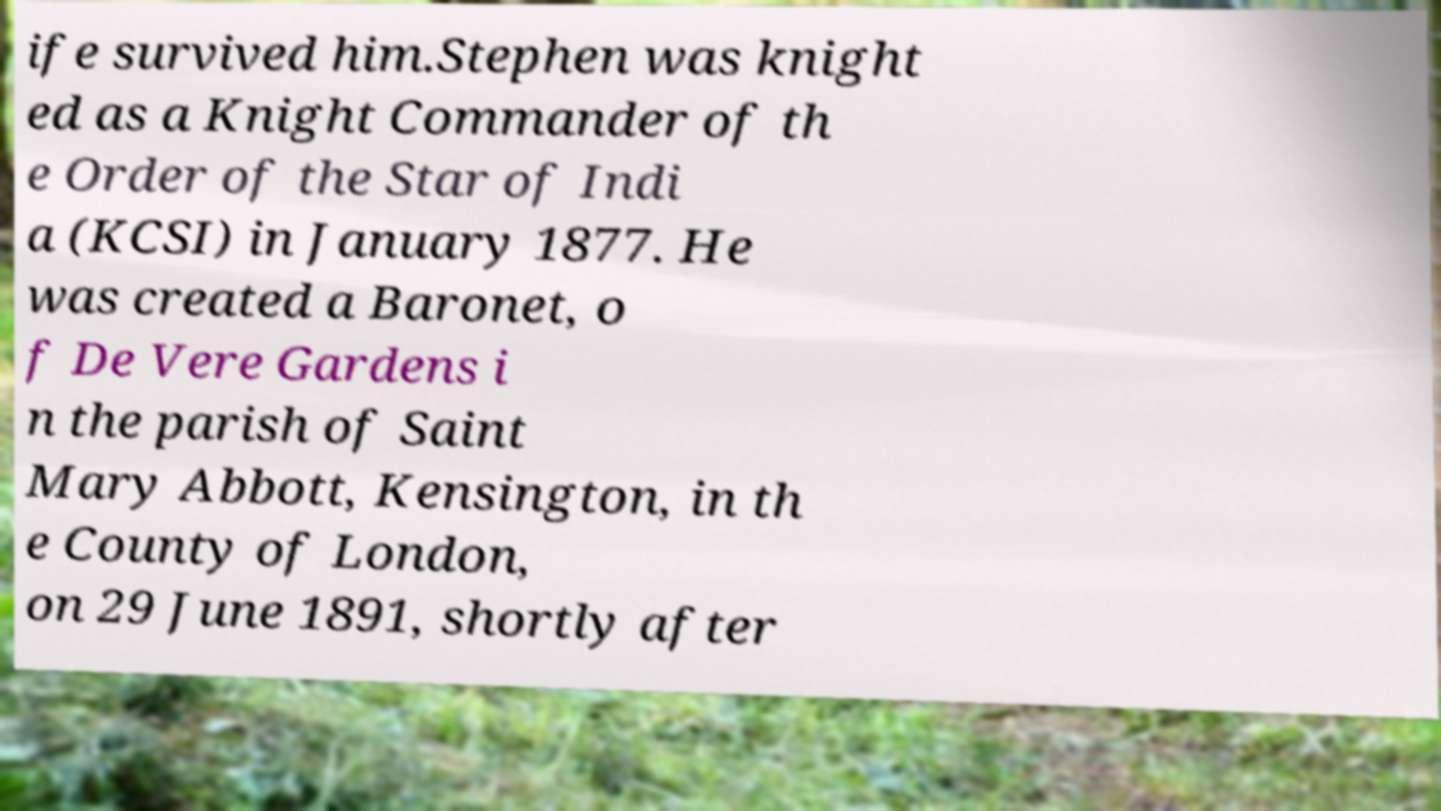Could you assist in decoding the text presented in this image and type it out clearly? ife survived him.Stephen was knight ed as a Knight Commander of th e Order of the Star of Indi a (KCSI) in January 1877. He was created a Baronet, o f De Vere Gardens i n the parish of Saint Mary Abbott, Kensington, in th e County of London, on 29 June 1891, shortly after 